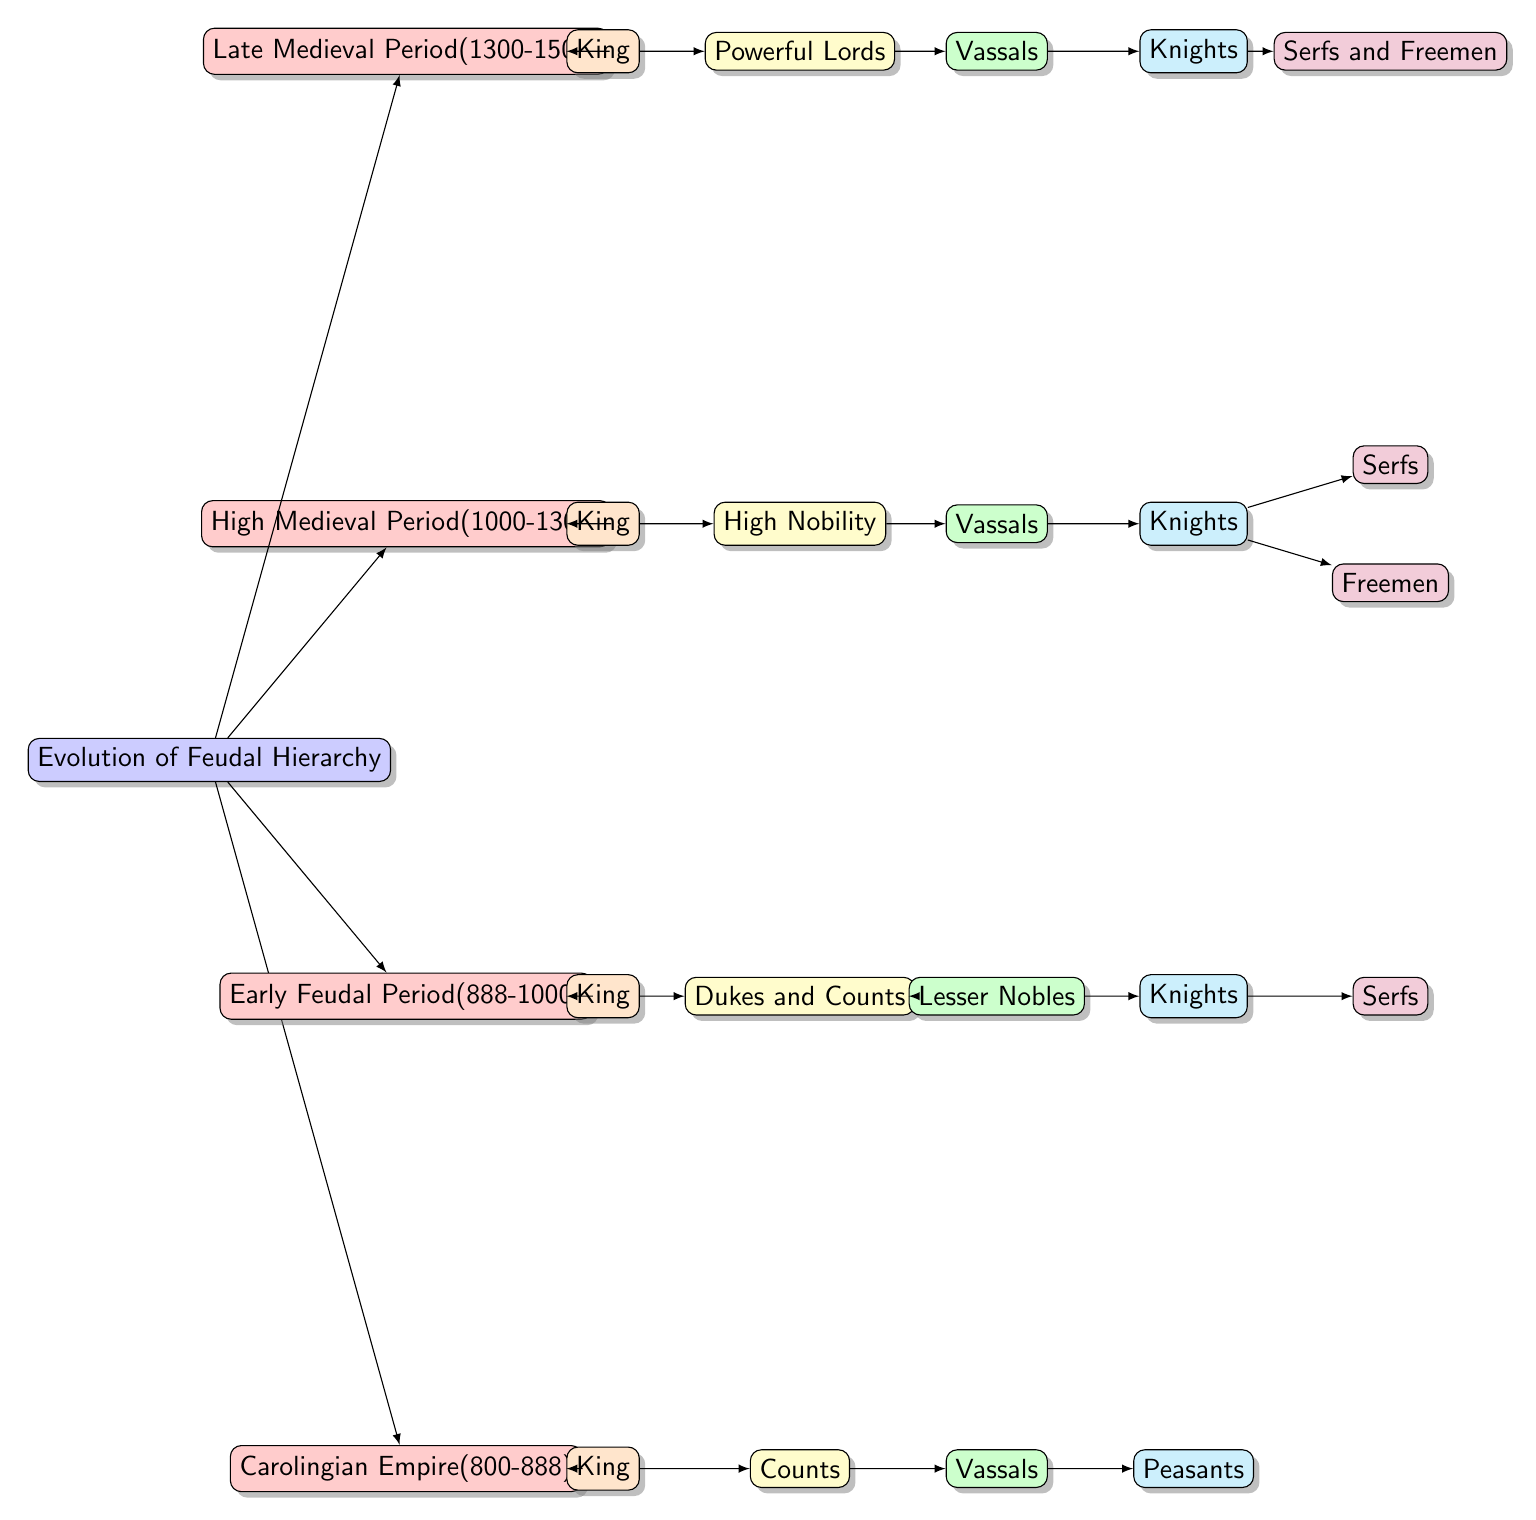What is the highest rank in the Carolingian Empire period? The diagram shows "King" as the highest rank under the Carolingian Empire (800-888) node.
Answer: King How many roles are listed under the High Medieval Period? Under the High Medieval Period (1000-1300), there are four roles: King, High Nobility, Vassals, and Knights.
Answer: 4 Which class directly serves the Powerful Lords in the Late Medieval Period? According to the diagram, the class that directly serves the Powerful Lords is "Vassals."
Answer: Vassals What are the two types of individuals that are grouped under Knights in the High Medieval Period? The diagram indicates that "Freemen" and "Serfs" are grouped under Knights in the High Medieval Period (1000-1300).
Answer: Freemen and Serfs How does the role of Dukes and Counts compare to that of Counts in the Early Feudal Period? The diagram reveals that Dukes and Counts is a higher hierarchy compared to Counts, which is a lesser class in the Early Feudal Period (888-1000).
Answer: Dukes and Counts are higher What is the starting point of the timeline depicted in the diagram? The timeline begins with the Carolingian Empire (800-888) as the first node in the flow chart.
Answer: Carolingian Empire (800-888) Which period introduced Knights as a specific role? Knights were introduced as a specific role during the Early Feudal Period (888-1000).
Answer: Early Feudal Period (888-1000) In the High Medieval Period, which role is directly subordinate to the King? The High Nobility is shown to be directly subordinate to the King in the High Medieval Period (1000-1300).
Answer: High Nobility How many total periods are represented in the diagram? The diagram clearly represents four distinct periods: Carolingian Empire, Early Feudal Period, High Medieval Period, and Late Medieval Period.
Answer: 4 